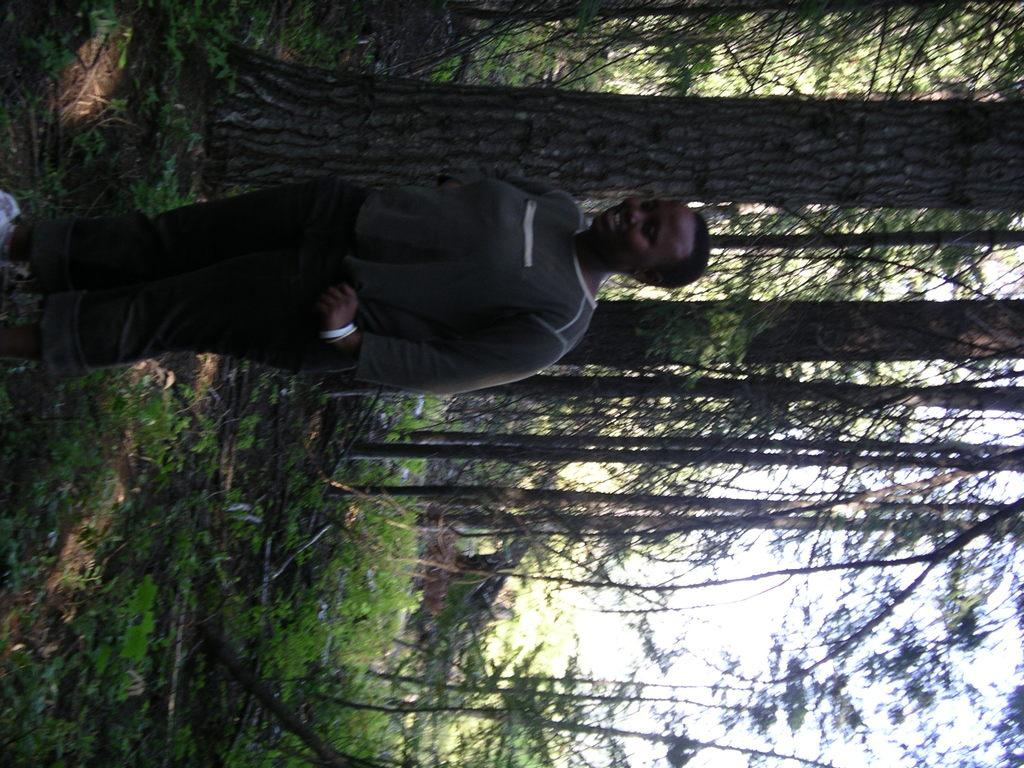Who or what is the main subject in the image? There is a person in the image. What is the person wearing? The person is wearing a dress. What can be seen in the background of the image? There are many trees and the sky visible in the background of the image. How many books can be seen on the person's head in the image? There are no books visible on the person's head in the image. 